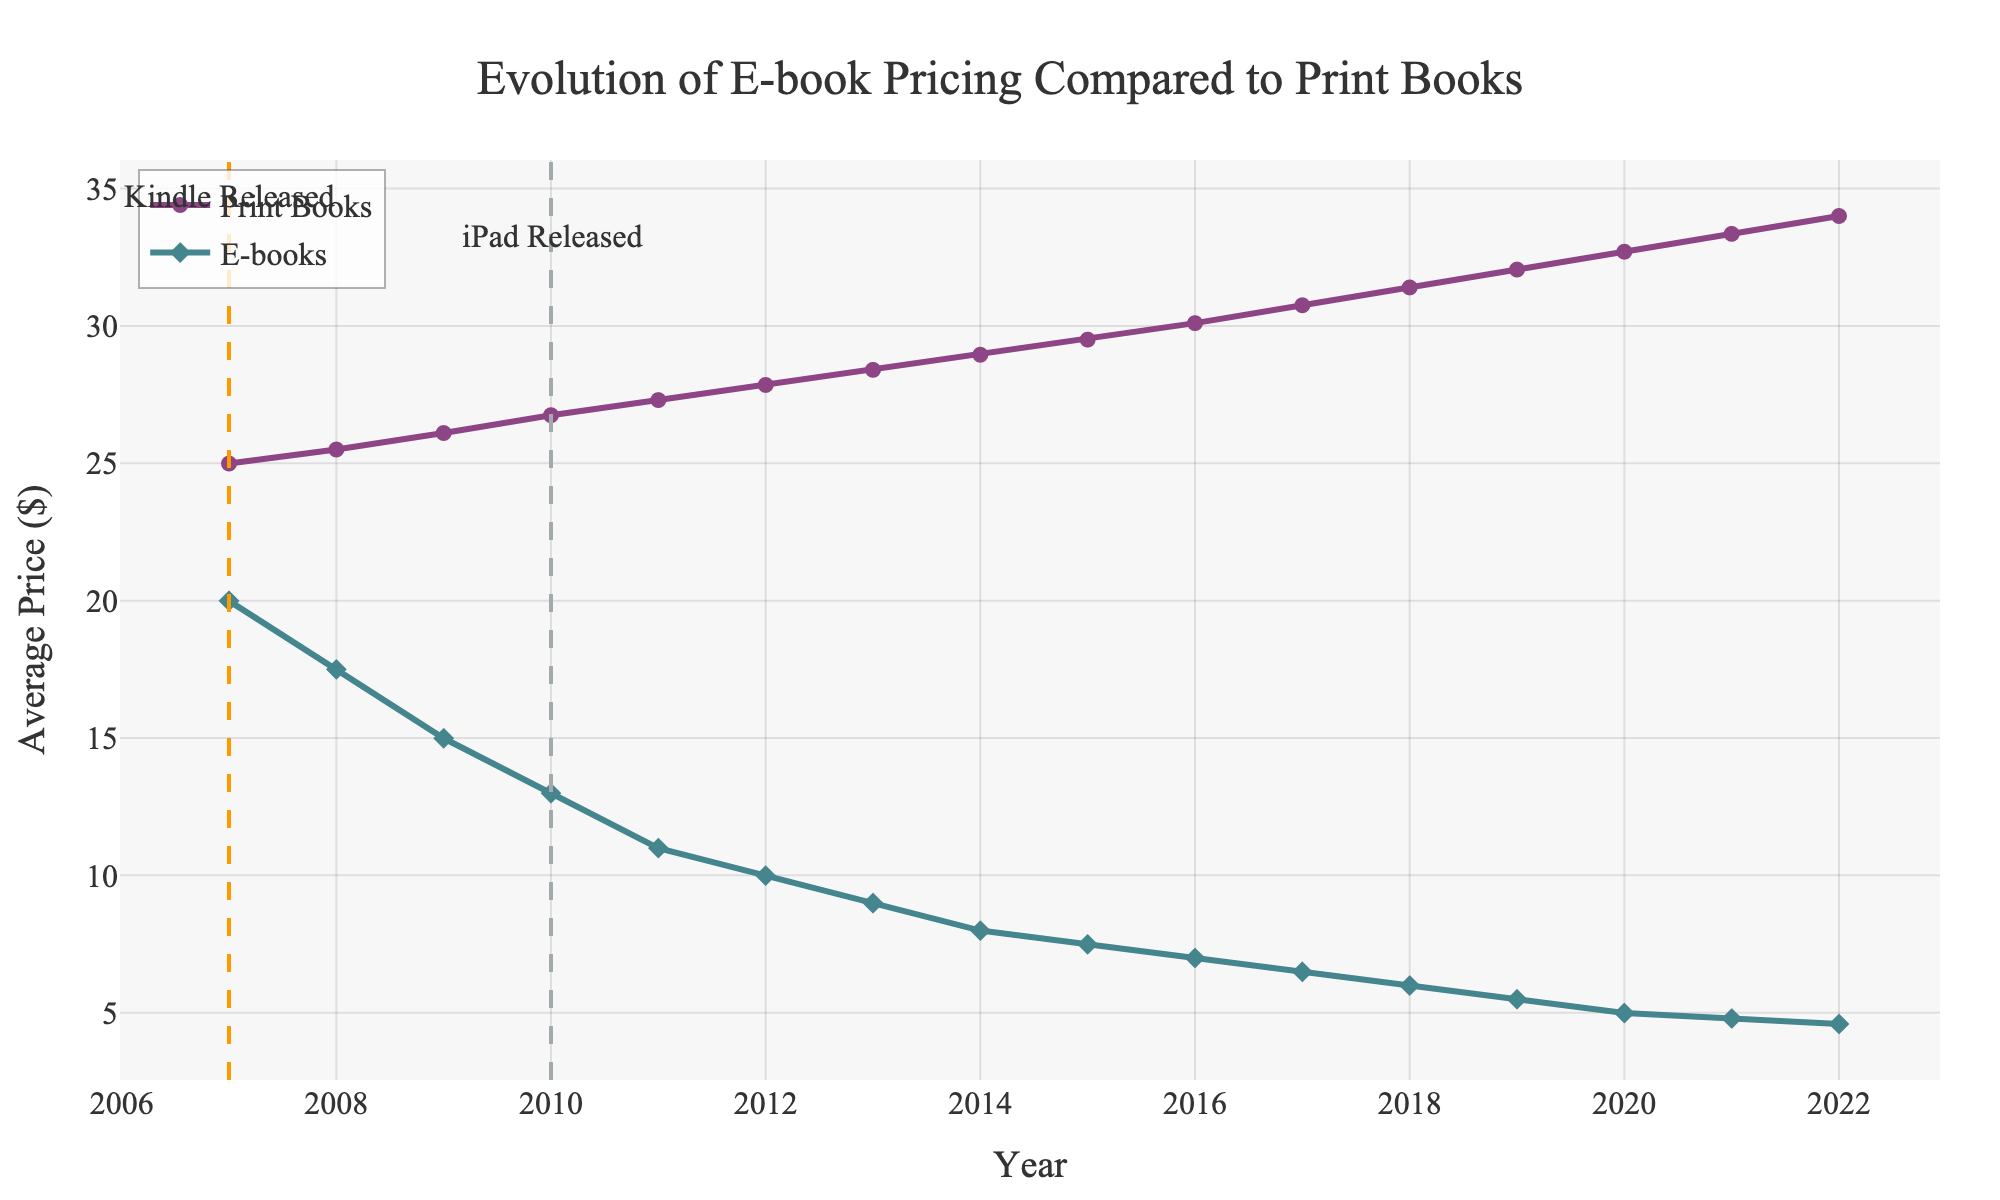What year was the average e-book price closest to $10? By examining the line chart, find the point on the e-book price line that is closest to $10. The data shows that the average e-book price in 2011 was $10.99, which is the closest to $10.
Answer: 2011 What was the price difference between average print books and e-books in 2007? Look at the prices in 2007 for both print books ($24.99) and e-books ($19.99), and then subtract the e-book price from the print book price. $24.99 - $19.99 = $5.00
Answer: $5.00 How did the average price of e-books change from 2010 to 2012? Locate the prices on the chart for e-books in 2010 ($12.99) and in 2012 ($9.99). Calculate the difference: $12.99 - $9.99 = $3.00. Thus, the average e-book price decreased by $3.00.
Answer: Decreased by $3.00 When was the iPad first released based on the chart annotations? Identify the vertical dashed line labeled "iPad Released" and note the corresponding year.
Answer: 2010 On average, how much did the price of print books increase per year from 2007 to 2022? Determine the difference in print book prices between 2007 ($24.99) and 2022 ($34.00): $34.00 - $24.99 = $9.01. Then, divide this difference by the number of years: 2022 - 2007 = 15 years. $9.01 / 15 = approximately $0.60 per year.
Answer: $0.60 per year By how much did the average price of e-books decrease from 2007 to 2022? Subtract the e-book price in 2022 ($4.59) from the price in 2007 ($19.99): $19.99 - $4.59 = $15.40.
Answer: $15.40 How many years after the Kindle release was the iPad released? Identify the years when Kindle (2007) and iPad (2010) were released from the annotations on the chart. Subtract 2007 from 2010: 2010 - 2007 = 3 years.
Answer: 3 years Which year saw the highest average print book price on the chart? Observe the line representing print book prices and find the peak value, which occurs in 2022 at $34.00.
Answer: 2022 What is the visual difference between the markers for print books and e-books in the line chart? The chart uses circles for print books and diamonds for e-books, as indicated by the markers in the legend.
Answer: Circles for print books, diamonds for e-books 